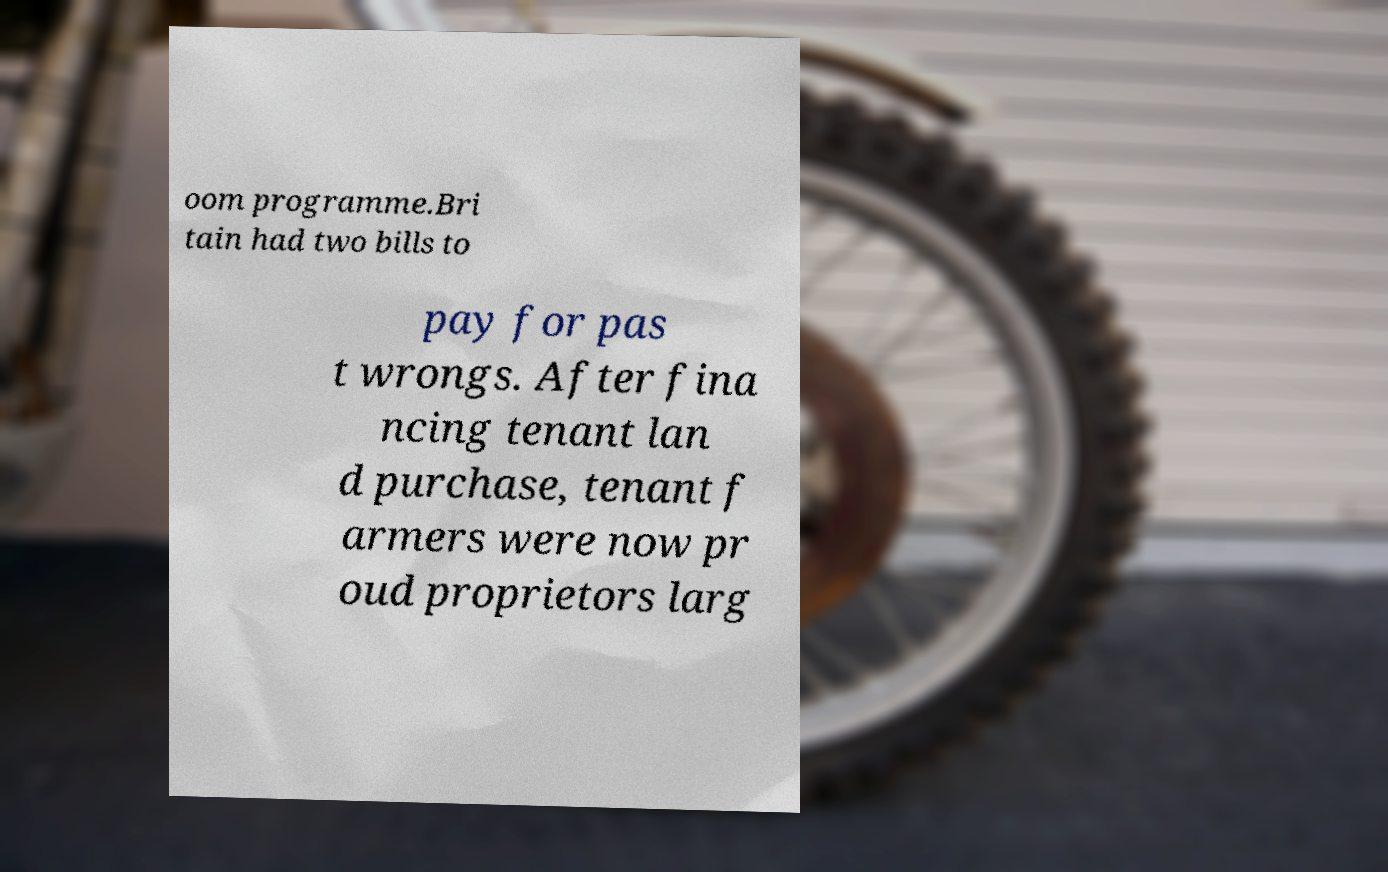For documentation purposes, I need the text within this image transcribed. Could you provide that? oom programme.Bri tain had two bills to pay for pas t wrongs. After fina ncing tenant lan d purchase, tenant f armers were now pr oud proprietors larg 